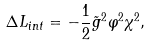<formula> <loc_0><loc_0><loc_500><loc_500>\Delta L _ { i n t } = - \frac { 1 } { 2 } \tilde { g } ^ { 2 } \varphi ^ { 2 } \chi ^ { 2 } ,</formula> 